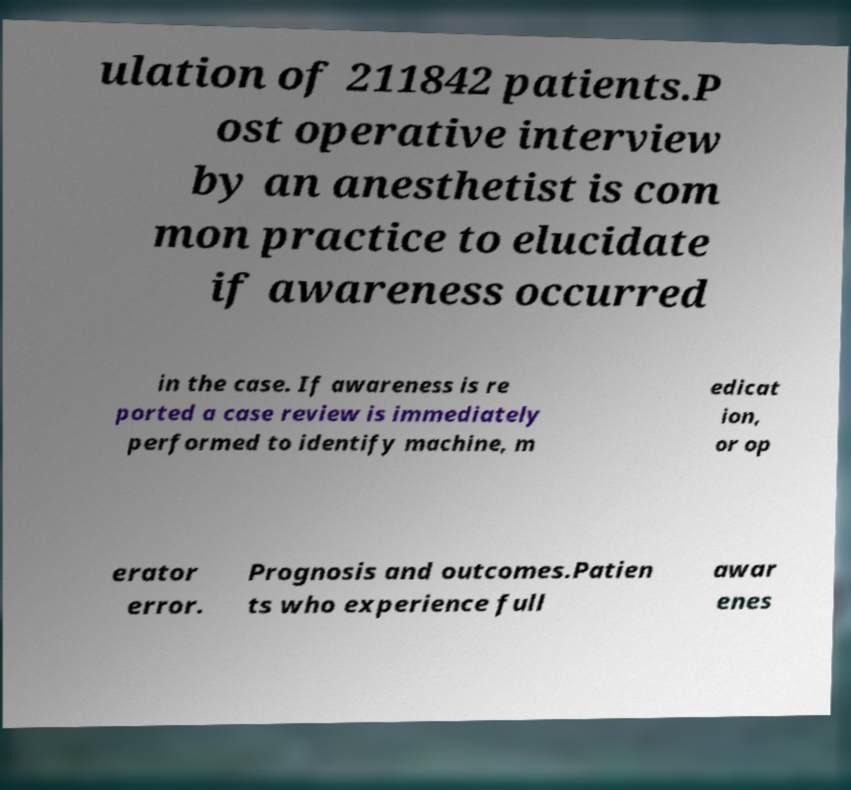Please read and relay the text visible in this image. What does it say? ulation of 211842 patients.P ost operative interview by an anesthetist is com mon practice to elucidate if awareness occurred in the case. If awareness is re ported a case review is immediately performed to identify machine, m edicat ion, or op erator error. Prognosis and outcomes.Patien ts who experience full awar enes 